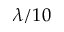<formula> <loc_0><loc_0><loc_500><loc_500>\lambda / 1 0</formula> 